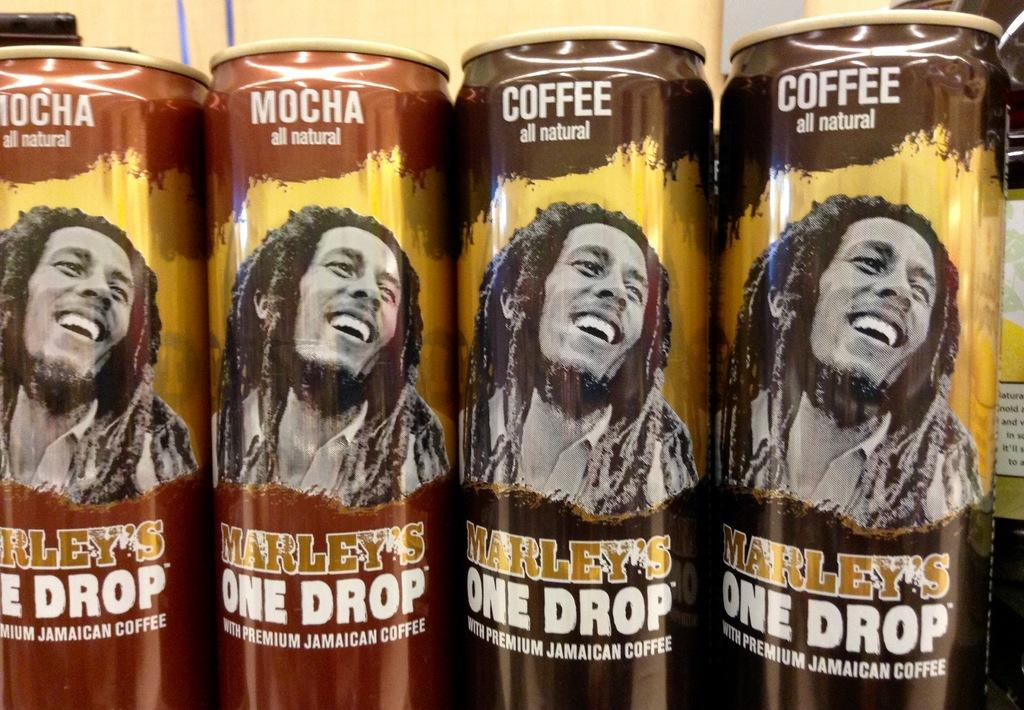<image>
Summarize the visual content of the image. Four cans of Marley's One Drop sit lined up on a shelf. 